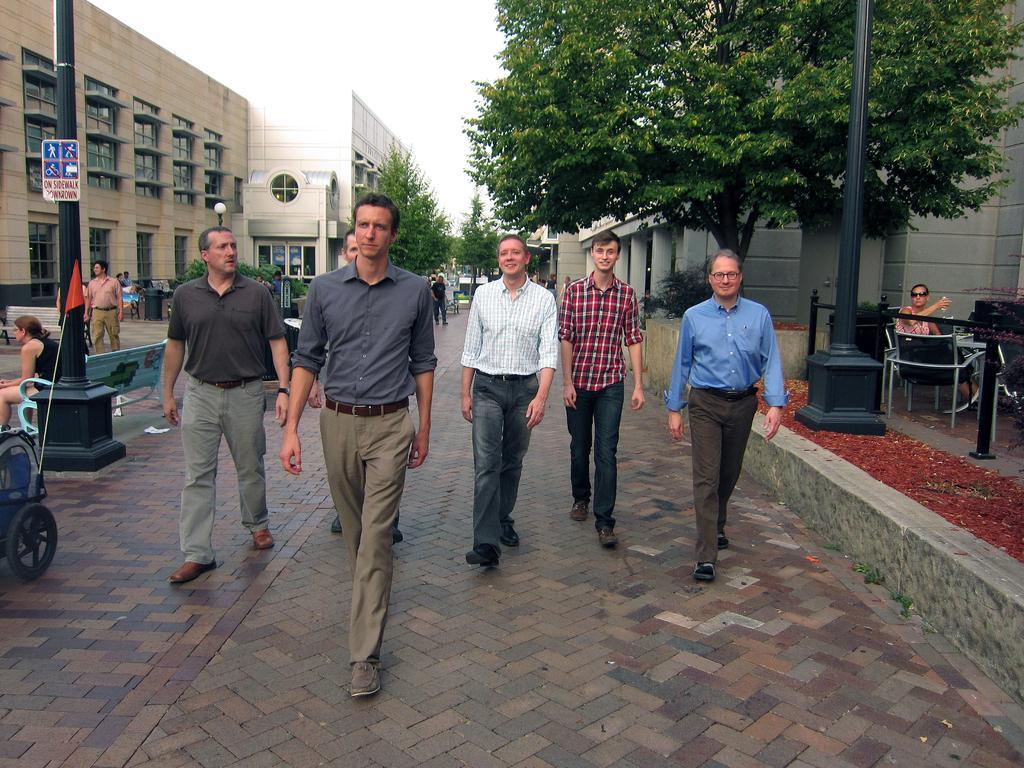Could you give a brief overview of what you see in this image? In this picture in the center there are persons walking. On the right side there is a person sitting on a chair and there is a black colour pole and there are trees, there is a building. In the background there are trees, persons and on the left side there are buildings, there are persons standing and sitting and there is a red colour flag and black colour pole 